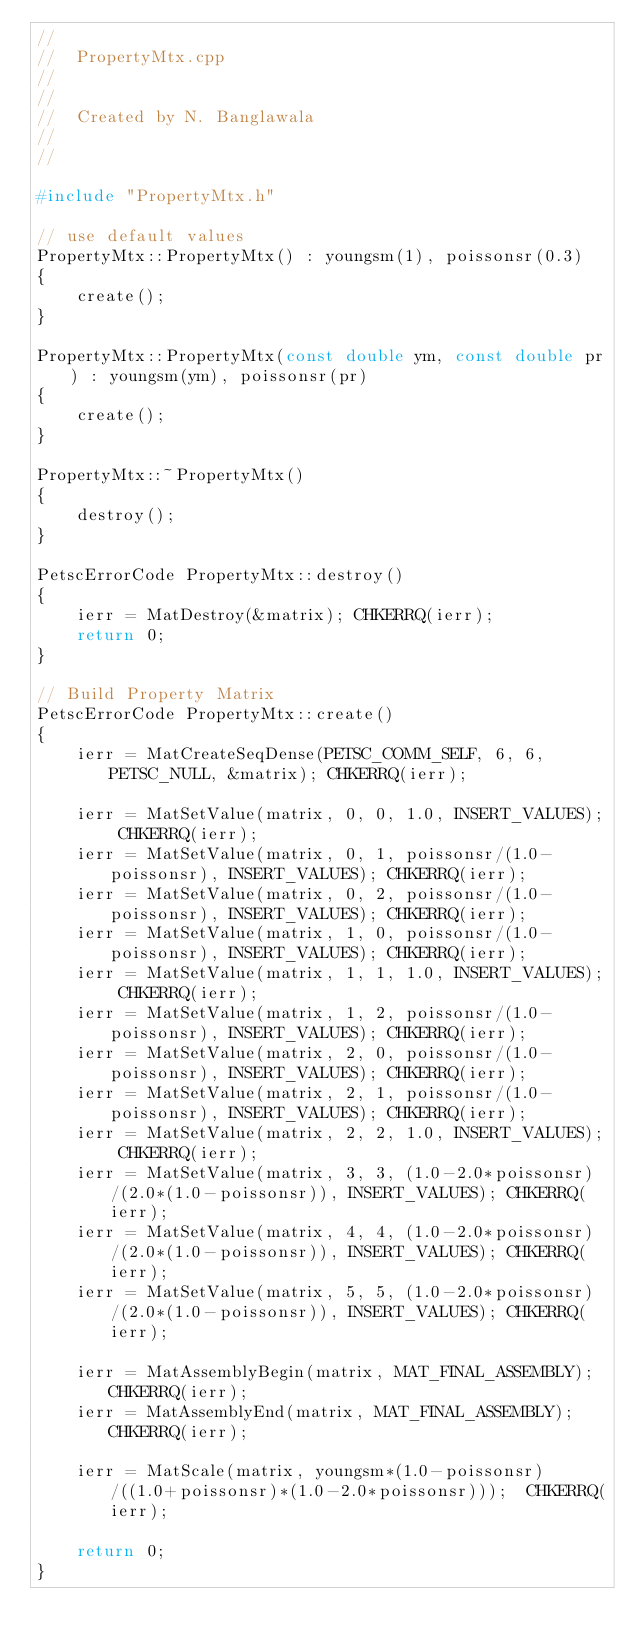Convert code to text. <code><loc_0><loc_0><loc_500><loc_500><_C++_>//
//  PropertyMtx.cpp
//  
//
//  Created by N. Banglawala
//
//

#include "PropertyMtx.h"

// use default values
PropertyMtx::PropertyMtx() : youngsm(1), poissonsr(0.3)
{
    create();
}

PropertyMtx::PropertyMtx(const double ym, const double pr) : youngsm(ym), poissonsr(pr)
{
    create();
}

PropertyMtx::~PropertyMtx()
{
    destroy();
}

PetscErrorCode PropertyMtx::destroy()
{
    ierr = MatDestroy(&matrix); CHKERRQ(ierr);
    return 0;
}

// Build Property Matrix
PetscErrorCode PropertyMtx::create()
{
    ierr = MatCreateSeqDense(PETSC_COMM_SELF, 6, 6, PETSC_NULL, &matrix); CHKERRQ(ierr);
    
    ierr = MatSetValue(matrix, 0, 0, 1.0, INSERT_VALUES); CHKERRQ(ierr);
    ierr = MatSetValue(matrix, 0, 1, poissonsr/(1.0-poissonsr), INSERT_VALUES); CHKERRQ(ierr);
    ierr = MatSetValue(matrix, 0, 2, poissonsr/(1.0-poissonsr), INSERT_VALUES); CHKERRQ(ierr);
    ierr = MatSetValue(matrix, 1, 0, poissonsr/(1.0-poissonsr), INSERT_VALUES); CHKERRQ(ierr);
    ierr = MatSetValue(matrix, 1, 1, 1.0, INSERT_VALUES); CHKERRQ(ierr);
    ierr = MatSetValue(matrix, 1, 2, poissonsr/(1.0-poissonsr), INSERT_VALUES); CHKERRQ(ierr);
    ierr = MatSetValue(matrix, 2, 0, poissonsr/(1.0-poissonsr), INSERT_VALUES); CHKERRQ(ierr);
    ierr = MatSetValue(matrix, 2, 1, poissonsr/(1.0-poissonsr), INSERT_VALUES); CHKERRQ(ierr);
    ierr = MatSetValue(matrix, 2, 2, 1.0, INSERT_VALUES); CHKERRQ(ierr);
    ierr = MatSetValue(matrix, 3, 3, (1.0-2.0*poissonsr)/(2.0*(1.0-poissonsr)), INSERT_VALUES); CHKERRQ(ierr);
    ierr = MatSetValue(matrix, 4, 4, (1.0-2.0*poissonsr)/(2.0*(1.0-poissonsr)), INSERT_VALUES); CHKERRQ(ierr);
    ierr = MatSetValue(matrix, 5, 5, (1.0-2.0*poissonsr)/(2.0*(1.0-poissonsr)), INSERT_VALUES); CHKERRQ(ierr);
    
    ierr = MatAssemblyBegin(matrix, MAT_FINAL_ASSEMBLY); CHKERRQ(ierr);
    ierr = MatAssemblyEnd(matrix, MAT_FINAL_ASSEMBLY); CHKERRQ(ierr);
    
    ierr = MatScale(matrix, youngsm*(1.0-poissonsr)/((1.0+poissonsr)*(1.0-2.0*poissonsr)));  CHKERRQ(ierr);
    
    return 0;
}



</code> 